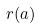<formula> <loc_0><loc_0><loc_500><loc_500>r ( a )</formula> 